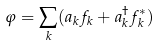Convert formula to latex. <formula><loc_0><loc_0><loc_500><loc_500>\varphi = \sum _ { k } ( a _ { k } f _ { k } + a ^ { \dagger } _ { k } f ^ { * } _ { k } )</formula> 